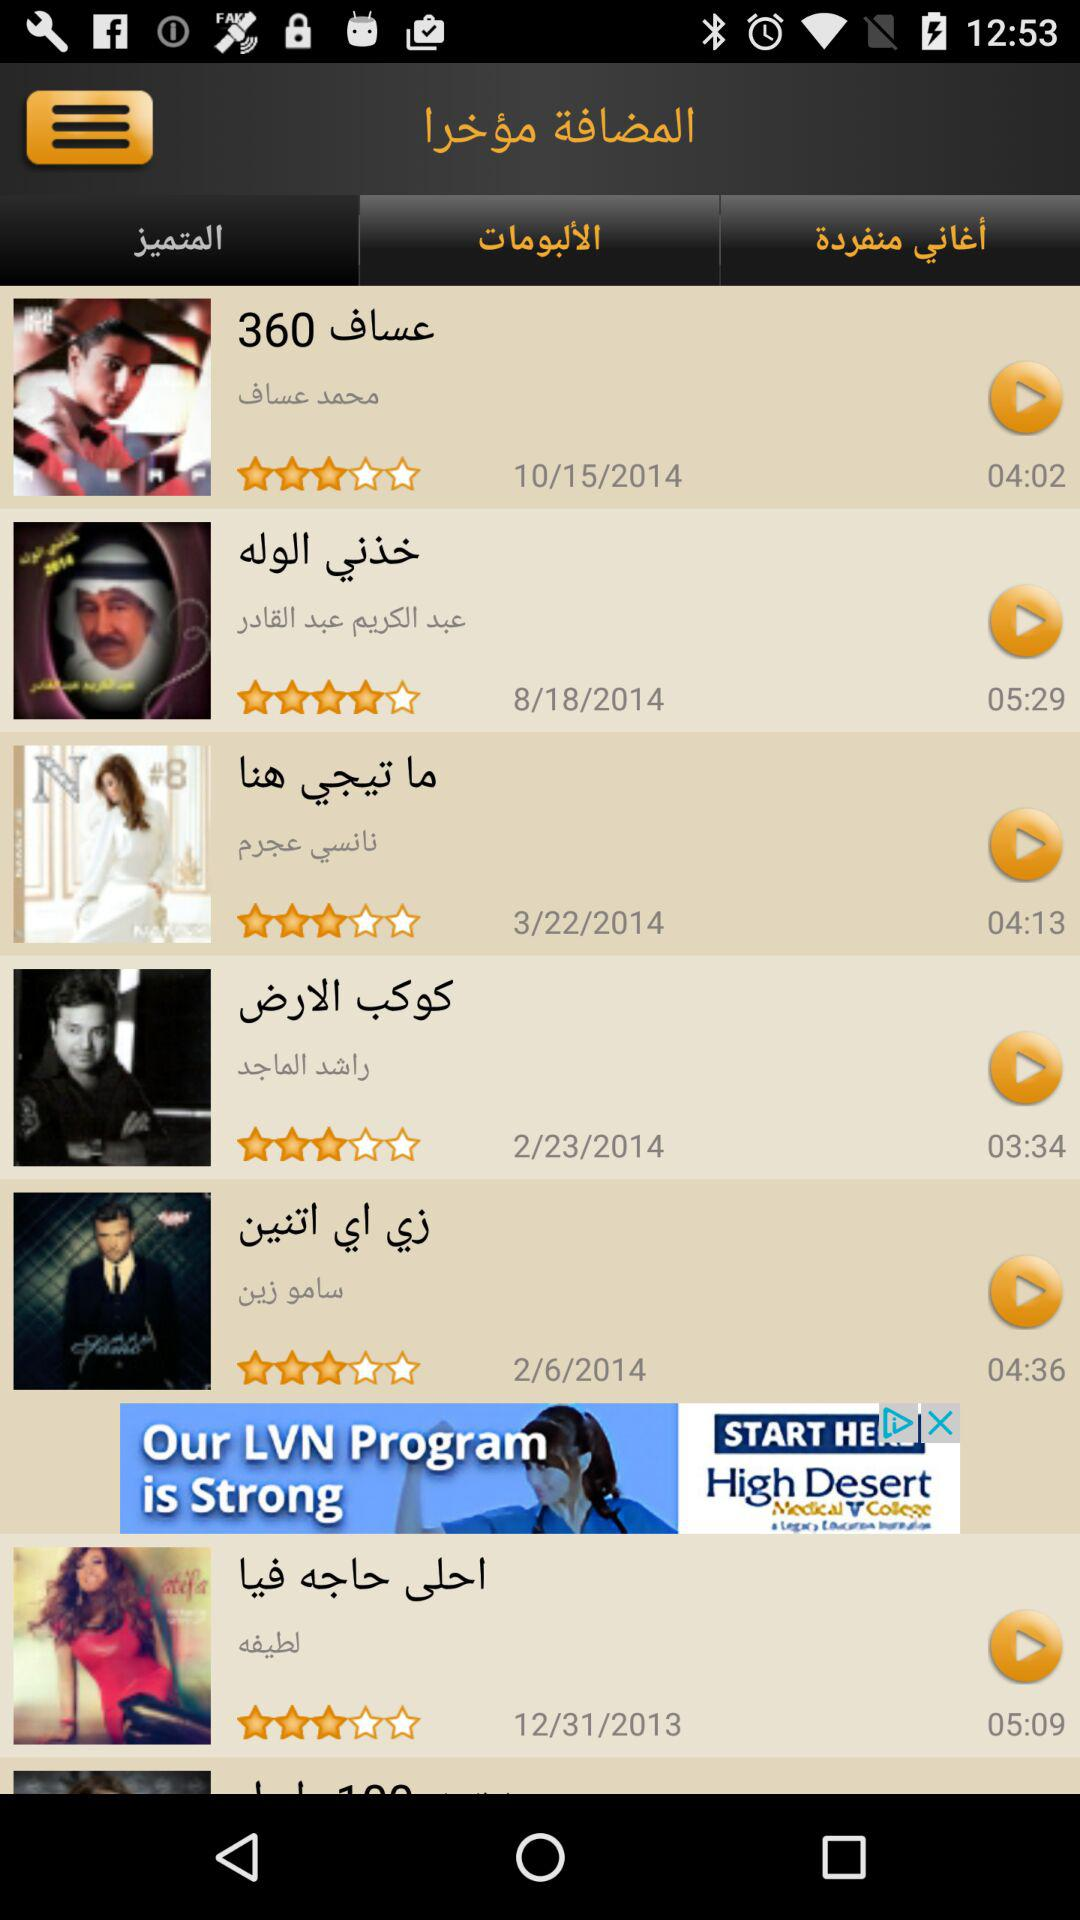How many items are in the recently added section?
Answer the question using a single word or phrase. 6 